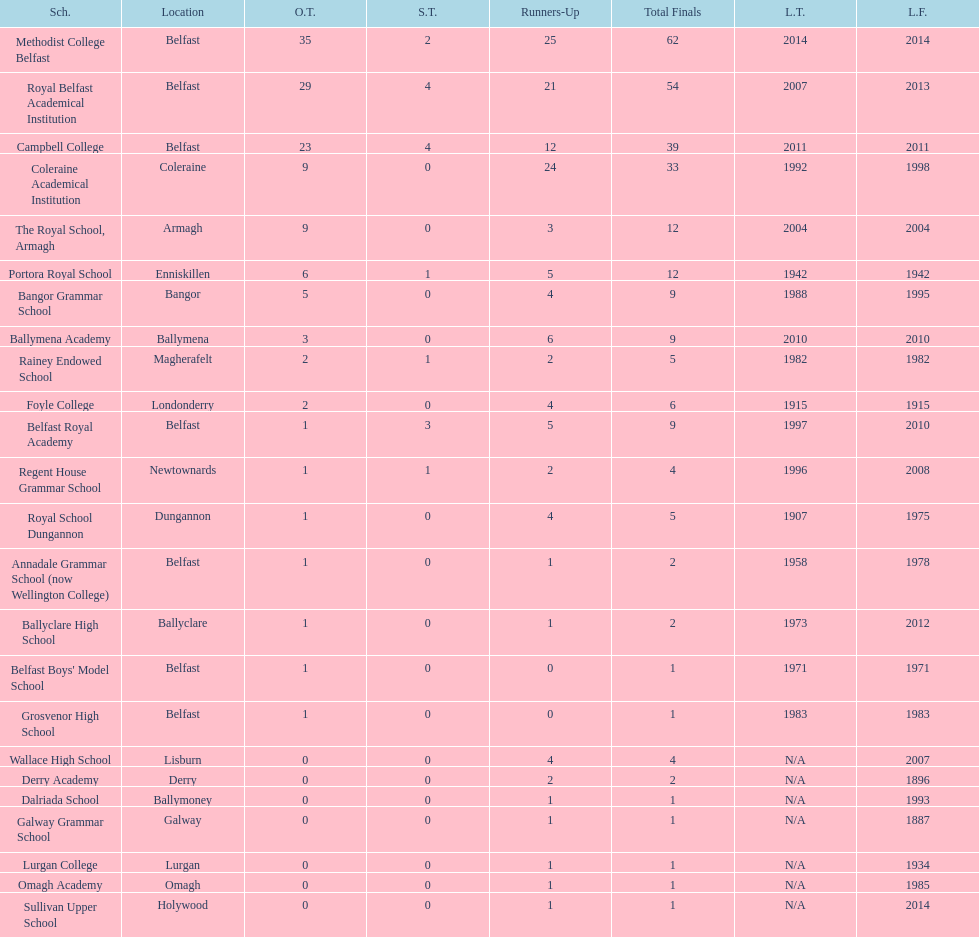Which schools have the largest number of shared titles? Royal Belfast Academical Institution, Campbell College. 